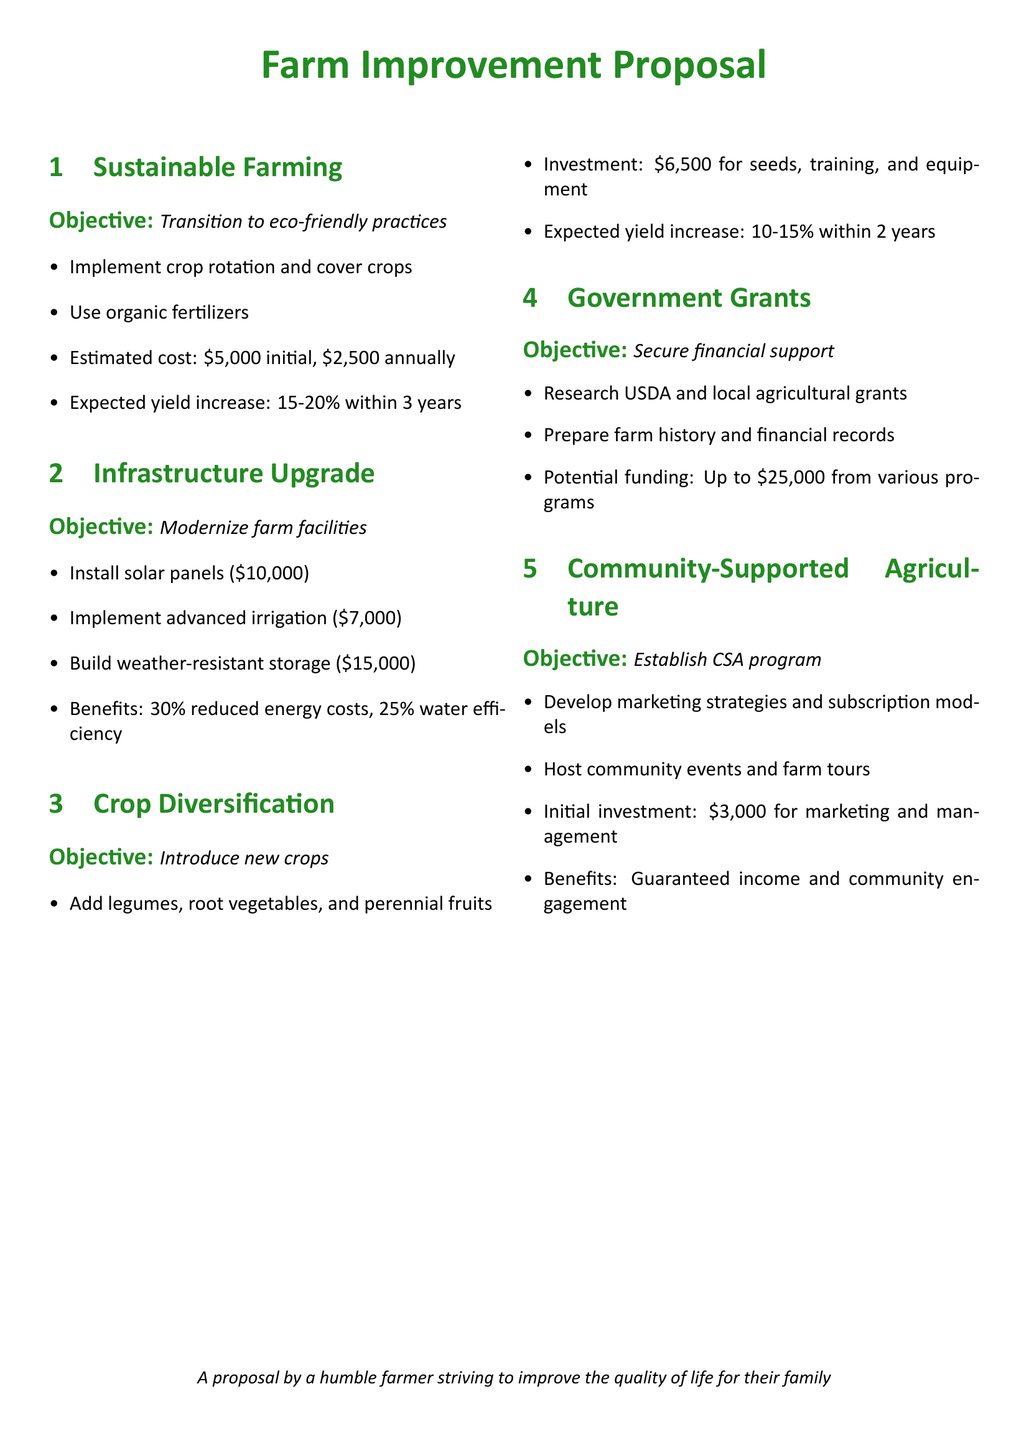What is the initial cost for sustainable farming? The initial cost for sustainable farming according to the proposal is $5,000.
Answer: $5,000 What is the expected yield increase for crop diversification? The expected yield increase for crop diversification is 10-15%.
Answer: 10-15% How much funding can be secured from government grants? The potential funding that can be secured from government grants is up to $25,000.
Answer: $25,000 What is included in the infrastructure upgrade proposal? The infrastructure upgrade proposal includes solar panels, advanced irrigation, and a weather-resistant storage unit.
Answer: Solar panels, advanced irrigation, weather-resistant storage unit What is the annual cost for sustainable farming practices? The annual cost for sustainable farming practices is estimated at $2,500.
Answer: $2,500 What is the total investment required for implementing a Community-Supported Agriculture program? The total investment required for the CSA program is $3,000.
Answer: $3,000 What crops are suggested for diversification? Suggested crops for diversification include legumes, root vegetables, and perennial fruits.
Answer: Legumes, root vegetables, perennial fruits What benefit is associated with the installation of solar panels? The benefit associated with the installation of solar panels is a 30% reduction in energy costs.
Answer: 30% reduced energy costs 